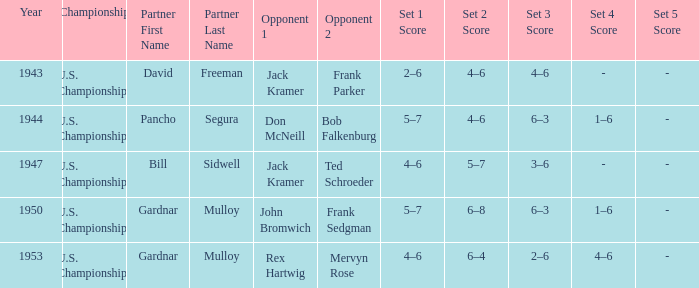Which Partner has Opponents in the final of john bromwich frank sedgman? Gardnar Mulloy. 